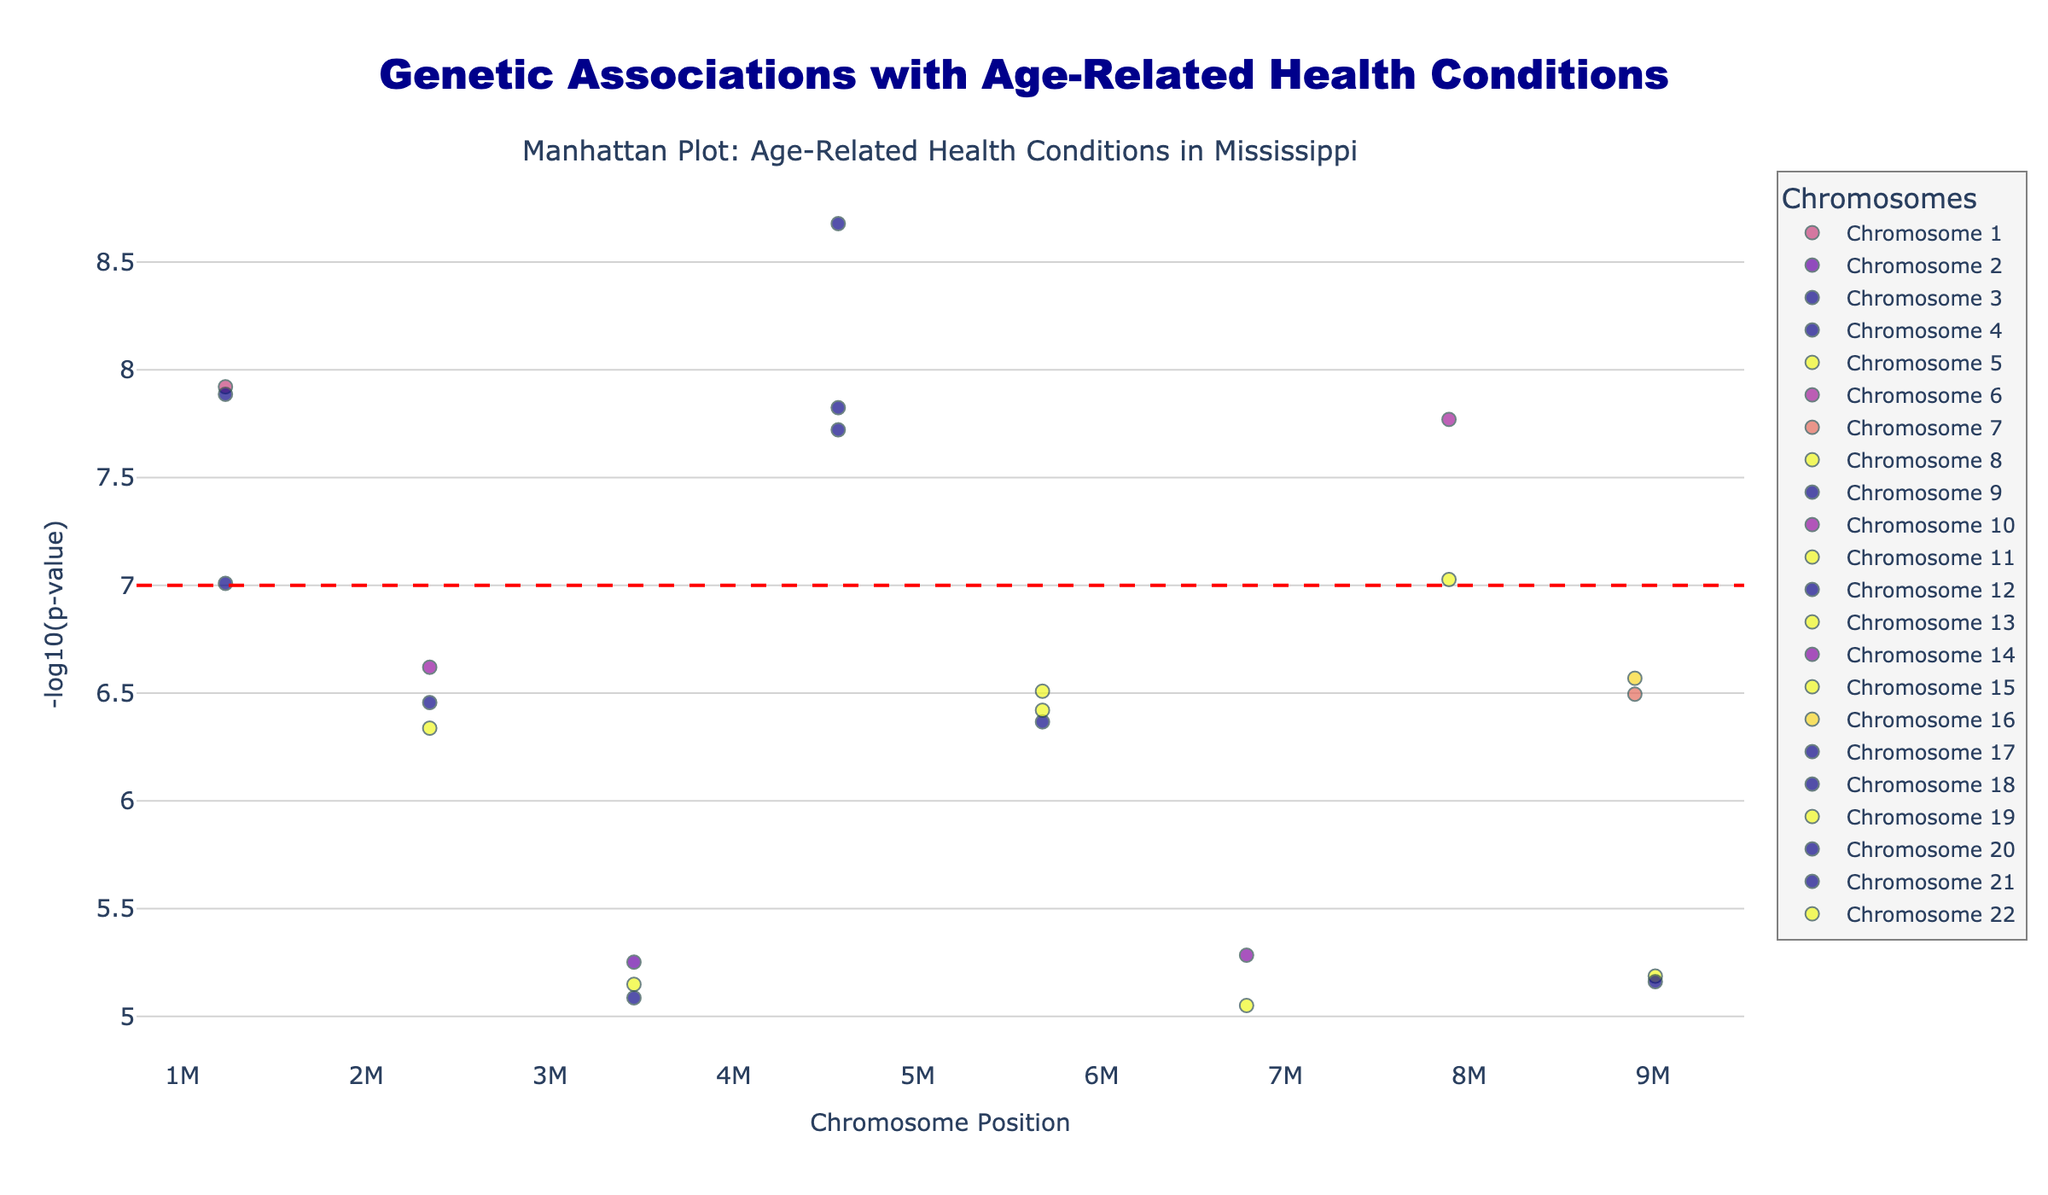What is the title of the figure? The title of the figure is clearly displayed at the top of the plot. It reads "Genetic Associations with Age-Related Health Conditions".
Answer: Genetic Associations with Age-Related Health Conditions How many data points are plotted on Chromosome 1? By examining the distinct markers for Chromosome 1 in the scatter plot, we can count the number of data points. There are 2 data points plotted for Chromosome 1.
Answer: 2 Which health condition is associated with the smallest p-value on Chromosome 1? By identifying the data points on Chromosome 1 and looking at the values along the y-axis (highest -log10(p-value)), we find that the smallest p-value corresponds to the SNP rs1801133, which is associated with Cardiovascular disease.
Answer: Cardiovascular disease What is the range of -log10(p-value) for the data points on Chromosome 19? For Chromosome 19, we need to find the highest and lowest -log10(p-value) values for the two data points. Observing the y-axis values, we identify the range between the highest (nearly 7.1) and lowest (approximately 6.4) -log10(p-value).
Answer: 6.4 to 7.1 Which chromosome has the most health conditions plotted? By visually comparing the number of data points for each chromosome, we see that Chromosome 1 has the most number of points plotted, i.e., 2.
Answer: 1 Which condition reaches statistical significance most prominently (highest peak) on the plot, and on which chromosome is it located? By identifying the highest peak on the plot, we see that the condition Alzheimer's disease has the most prominent peak, located on Chromosome 3 with a -log10(p-value) close to 9.
Answer: Alzheimer's disease, Chromosome 3 What similarities can be observed between the conditions on Chromosome 7 and Chromosome 9? Both Chromosome 7 and Chromosome 9 have data points associated with Age-related macular degeneration. Confirming from the figure, both chromosomes display a similar peak around -log10(p-value) of 6-8.
Answer: Age-related macular degeneration Compare the p-values of Age-related macular degeneration on Chromosome 7 and Chromosome 9. Which has a higher significance level? By comparing the -log10(p-value) values on Chromosome 7 and Chromosome 9 for Age-related macular degeneration, we see that the data point on Chromosome 9 (higher -log10(p-value)) represents a more significant result.
Answer: Chromosome 9 Is there any condition related to hyperlipidemia represented in the figure? If so, on which chromosome is it? By examining the condition labels, we identify one data point associated with hyperlipidemia. It is located on Chromosome 4.
Answer: Yes, Chromosome 4 